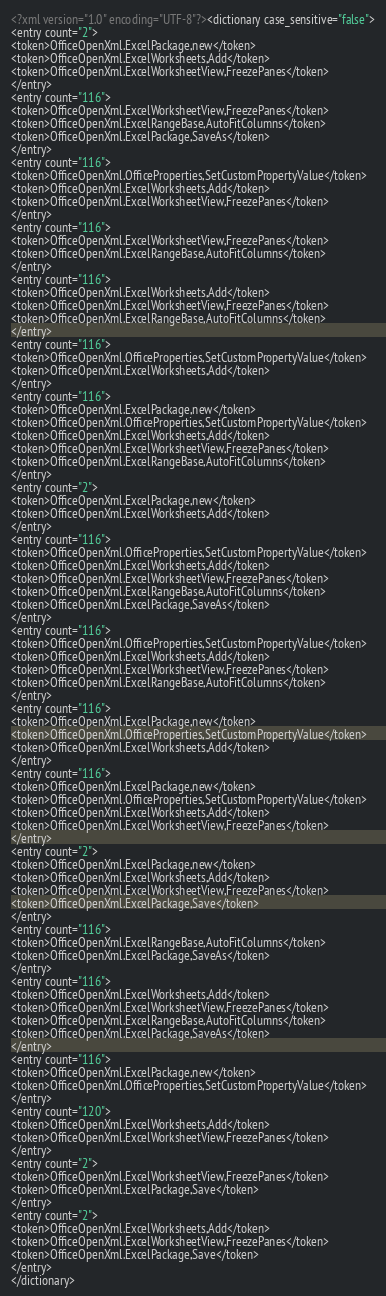Convert code to text. <code><loc_0><loc_0><loc_500><loc_500><_XML_><?xml version="1.0" encoding="UTF-8"?><dictionary case_sensitive="false">
<entry count="2">
<token>OfficeOpenXml.ExcelPackage,new</token>
<token>OfficeOpenXml.ExcelWorksheets,Add</token>
<token>OfficeOpenXml.ExcelWorksheetView,FreezePanes</token>
</entry>
<entry count="116">
<token>OfficeOpenXml.ExcelWorksheetView,FreezePanes</token>
<token>OfficeOpenXml.ExcelRangeBase,AutoFitColumns</token>
<token>OfficeOpenXml.ExcelPackage,SaveAs</token>
</entry>
<entry count="116">
<token>OfficeOpenXml.OfficeProperties,SetCustomPropertyValue</token>
<token>OfficeOpenXml.ExcelWorksheets,Add</token>
<token>OfficeOpenXml.ExcelWorksheetView,FreezePanes</token>
</entry>
<entry count="116">
<token>OfficeOpenXml.ExcelWorksheetView,FreezePanes</token>
<token>OfficeOpenXml.ExcelRangeBase,AutoFitColumns</token>
</entry>
<entry count="116">
<token>OfficeOpenXml.ExcelWorksheets,Add</token>
<token>OfficeOpenXml.ExcelWorksheetView,FreezePanes</token>
<token>OfficeOpenXml.ExcelRangeBase,AutoFitColumns</token>
</entry>
<entry count="116">
<token>OfficeOpenXml.OfficeProperties,SetCustomPropertyValue</token>
<token>OfficeOpenXml.ExcelWorksheets,Add</token>
</entry>
<entry count="116">
<token>OfficeOpenXml.ExcelPackage,new</token>
<token>OfficeOpenXml.OfficeProperties,SetCustomPropertyValue</token>
<token>OfficeOpenXml.ExcelWorksheets,Add</token>
<token>OfficeOpenXml.ExcelWorksheetView,FreezePanes</token>
<token>OfficeOpenXml.ExcelRangeBase,AutoFitColumns</token>
</entry>
<entry count="2">
<token>OfficeOpenXml.ExcelPackage,new</token>
<token>OfficeOpenXml.ExcelWorksheets,Add</token>
</entry>
<entry count="116">
<token>OfficeOpenXml.OfficeProperties,SetCustomPropertyValue</token>
<token>OfficeOpenXml.ExcelWorksheets,Add</token>
<token>OfficeOpenXml.ExcelWorksheetView,FreezePanes</token>
<token>OfficeOpenXml.ExcelRangeBase,AutoFitColumns</token>
<token>OfficeOpenXml.ExcelPackage,SaveAs</token>
</entry>
<entry count="116">
<token>OfficeOpenXml.OfficeProperties,SetCustomPropertyValue</token>
<token>OfficeOpenXml.ExcelWorksheets,Add</token>
<token>OfficeOpenXml.ExcelWorksheetView,FreezePanes</token>
<token>OfficeOpenXml.ExcelRangeBase,AutoFitColumns</token>
</entry>
<entry count="116">
<token>OfficeOpenXml.ExcelPackage,new</token>
<token>OfficeOpenXml.OfficeProperties,SetCustomPropertyValue</token>
<token>OfficeOpenXml.ExcelWorksheets,Add</token>
</entry>
<entry count="116">
<token>OfficeOpenXml.ExcelPackage,new</token>
<token>OfficeOpenXml.OfficeProperties,SetCustomPropertyValue</token>
<token>OfficeOpenXml.ExcelWorksheets,Add</token>
<token>OfficeOpenXml.ExcelWorksheetView,FreezePanes</token>
</entry>
<entry count="2">
<token>OfficeOpenXml.ExcelPackage,new</token>
<token>OfficeOpenXml.ExcelWorksheets,Add</token>
<token>OfficeOpenXml.ExcelWorksheetView,FreezePanes</token>
<token>OfficeOpenXml.ExcelPackage,Save</token>
</entry>
<entry count="116">
<token>OfficeOpenXml.ExcelRangeBase,AutoFitColumns</token>
<token>OfficeOpenXml.ExcelPackage,SaveAs</token>
</entry>
<entry count="116">
<token>OfficeOpenXml.ExcelWorksheets,Add</token>
<token>OfficeOpenXml.ExcelWorksheetView,FreezePanes</token>
<token>OfficeOpenXml.ExcelRangeBase,AutoFitColumns</token>
<token>OfficeOpenXml.ExcelPackage,SaveAs</token>
</entry>
<entry count="116">
<token>OfficeOpenXml.ExcelPackage,new</token>
<token>OfficeOpenXml.OfficeProperties,SetCustomPropertyValue</token>
</entry>
<entry count="120">
<token>OfficeOpenXml.ExcelWorksheets,Add</token>
<token>OfficeOpenXml.ExcelWorksheetView,FreezePanes</token>
</entry>
<entry count="2">
<token>OfficeOpenXml.ExcelWorksheetView,FreezePanes</token>
<token>OfficeOpenXml.ExcelPackage,Save</token>
</entry>
<entry count="2">
<token>OfficeOpenXml.ExcelWorksheets,Add</token>
<token>OfficeOpenXml.ExcelWorksheetView,FreezePanes</token>
<token>OfficeOpenXml.ExcelPackage,Save</token>
</entry>
</dictionary>
</code> 